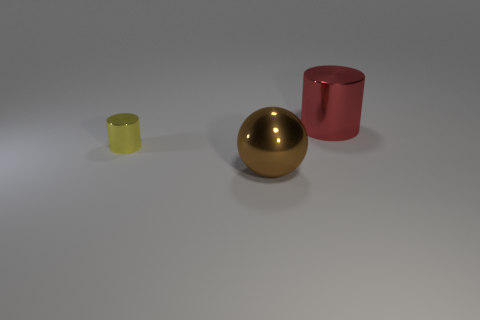Add 3 shiny cylinders. How many objects exist? 6 Subtract all balls. How many objects are left? 2 Subtract 0 red balls. How many objects are left? 3 Subtract all blue shiny objects. Subtract all yellow objects. How many objects are left? 2 Add 3 tiny cylinders. How many tiny cylinders are left? 4 Add 3 brown shiny spheres. How many brown shiny spheres exist? 4 